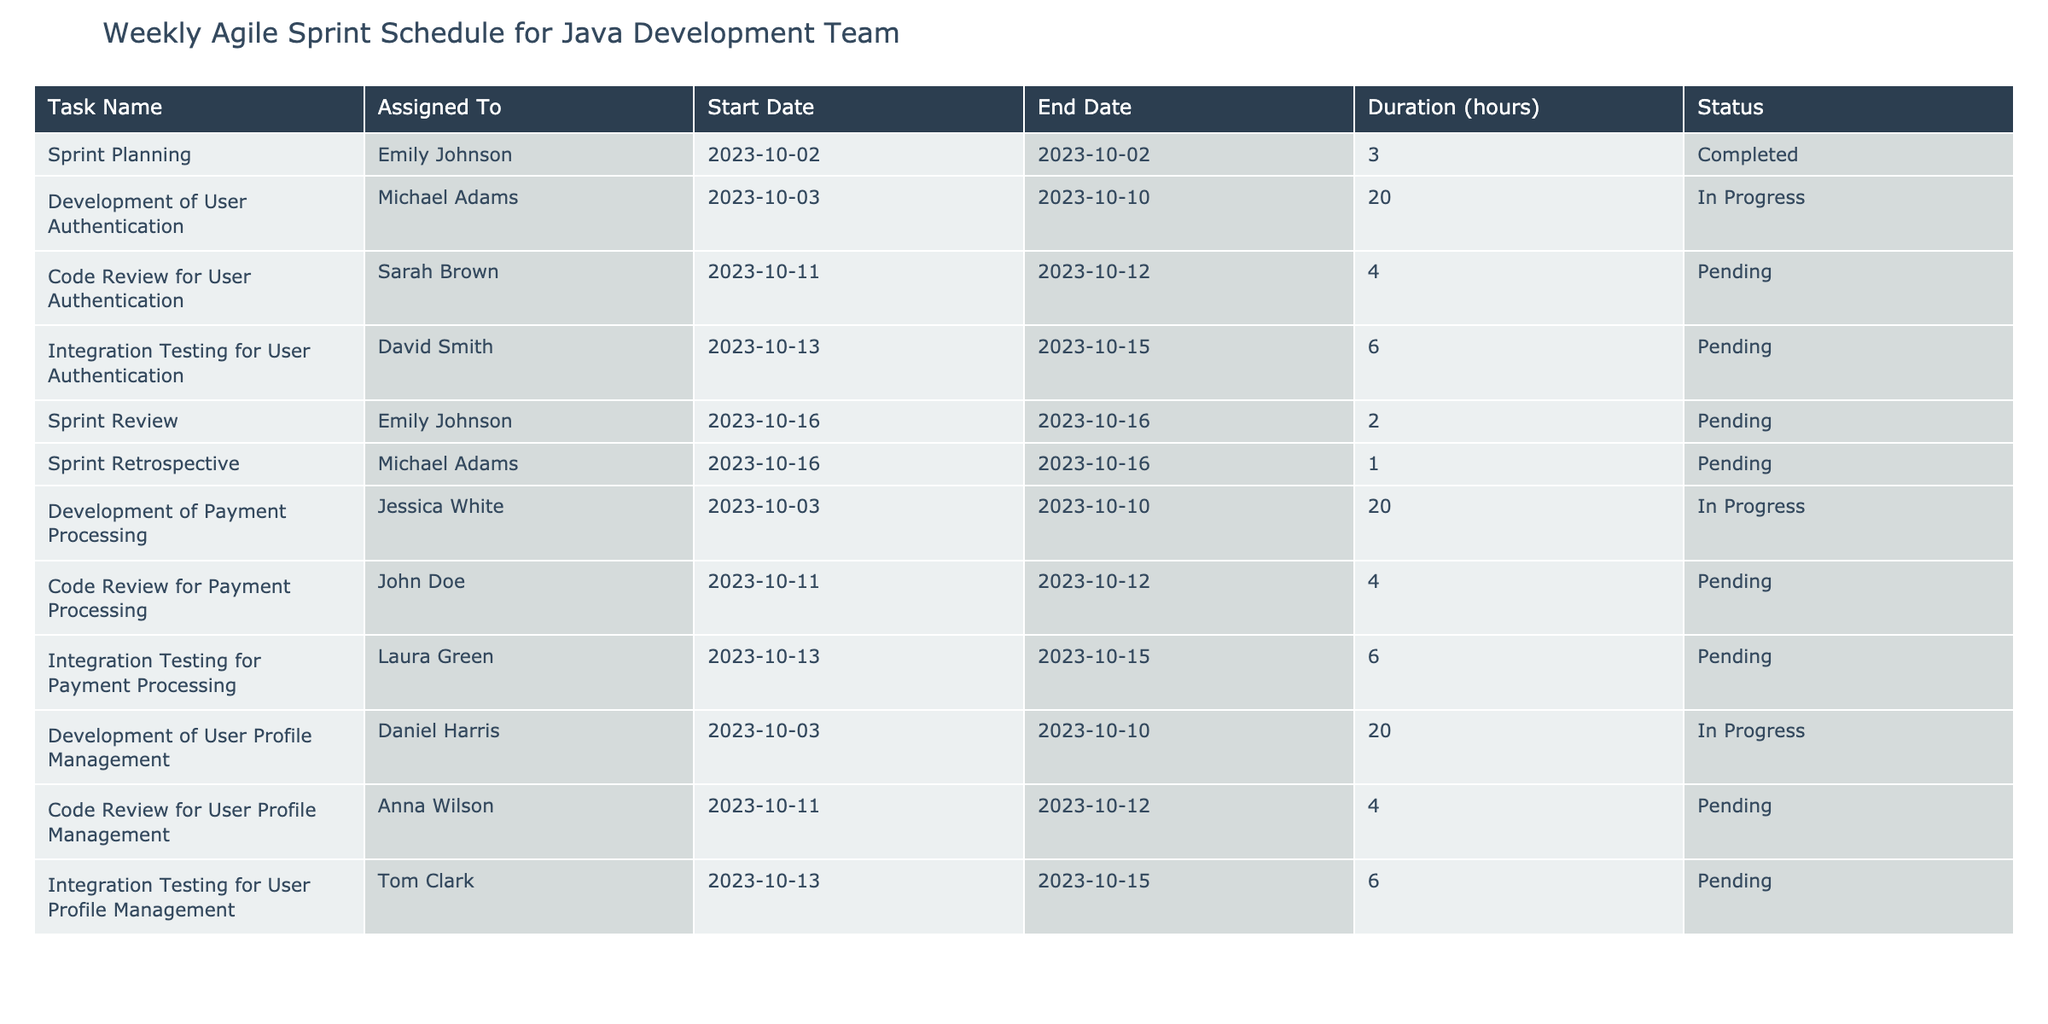What task is assigned to Emily Johnson? From the table, we can see that Emily Johnson is assigned to two tasks: "Sprint Planning" and "Sprint Review." The task listed first is "Sprint Planning," which is the only task that she has completed so far.
Answer: Sprint Planning What is the status of the "Code Review for User Profile Management"? The table lists "Code Review for User Profile Management" with a status of "Pending." This indicates that the task has not yet begun or is awaiting someone to start it.
Answer: Pending How many hours are estimated for the "Integration Testing for User Authentication"? The table shows that "Integration Testing for User Authentication" has an estimated duration of 6 hours. This can be taken directly from the "Duration (hours)" column corresponding to that task.
Answer: 6 hours Which team member is working on the "Development of Payment Processing"? According to the table, "Development of Payment Processing" is assigned to Jessica White. She is the one carrying out this task from October 3 to October 10.
Answer: Jessica White What tasks are scheduled to be completed on October 16? There are two tasks on October 16: "Sprint Review" and "Sprint Retrospective." We can find these tasks by checking the "Start Date" and "End Date" columns for that particular date.
Answer: Sprint Review and Sprint Retrospective What are the total estimated working hours for all development tasks assigned to Michael Adams? Michael Adams is assigned to two tasks: "Development of User Authentication" and "Sprint Retrospective." The total hours from the table are 20 hours (Development of User Authentication) and 1 hour (Sprint Retrospective), totaling 21 hours.
Answer: 21 hours Is there any task assigned to Sarah Brown? Yes, Sarah Brown is assigned to "Code Review for User Authentication," which is marked as pending according to the table.
Answer: Yes Which tasks have not yet started? The tasks that have not started are those marked as "Pending." These include "Code Review for User Authentication," "Integration Testing for User Authentication," "Code Review for Payment Processing," "Integration Testing for Payment Processing," "Code Review for User Profile Management," and "Integration Testing for User Profile Management." Therefore, there are six pending tasks.
Answer: 6 tasks What is the total duration of all tasks currently in progress? The tasks currently in progress are "Development of User Authentication," "Development of Payment Processing," and "Development of User Profile Management." The total duration for these is 20 hours each, which sums up to 20 + 20 + 20 = 60 hours.
Answer: 60 hours 